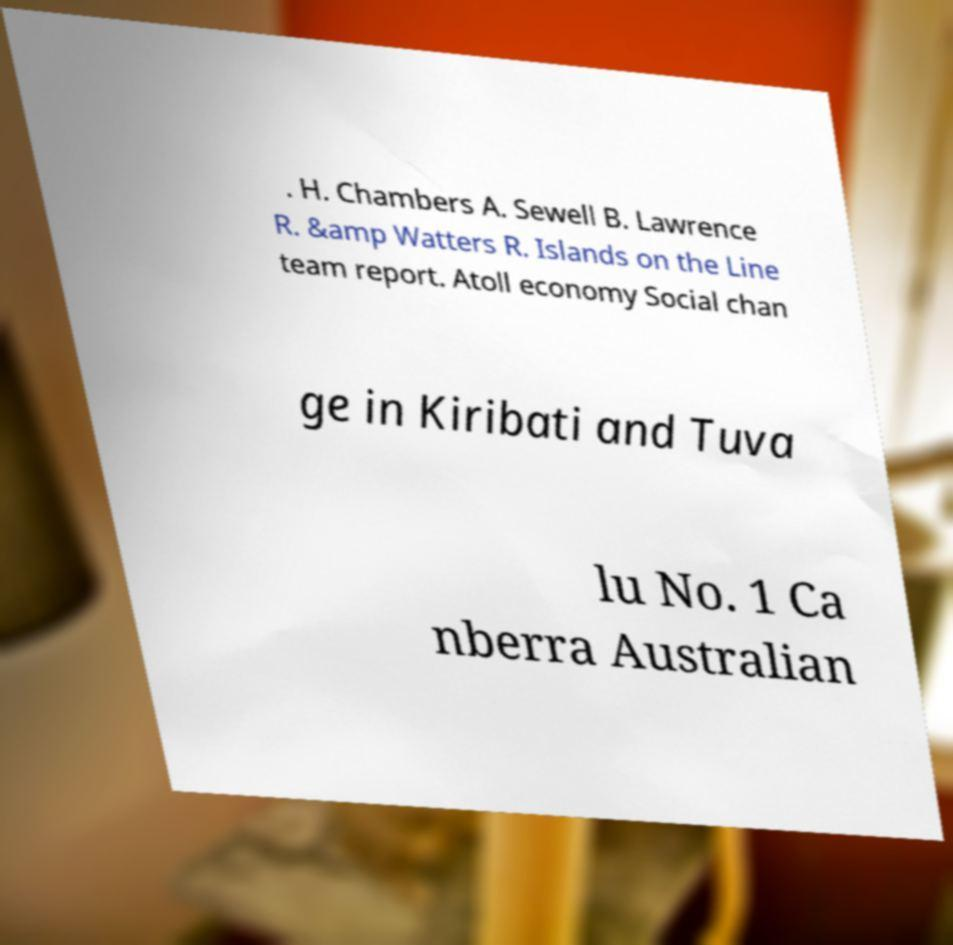Please read and relay the text visible in this image. What does it say? . H. Chambers A. Sewell B. Lawrence R. &amp Watters R. Islands on the Line team report. Atoll economy Social chan ge in Kiribati and Tuva lu No. 1 Ca nberra Australian 